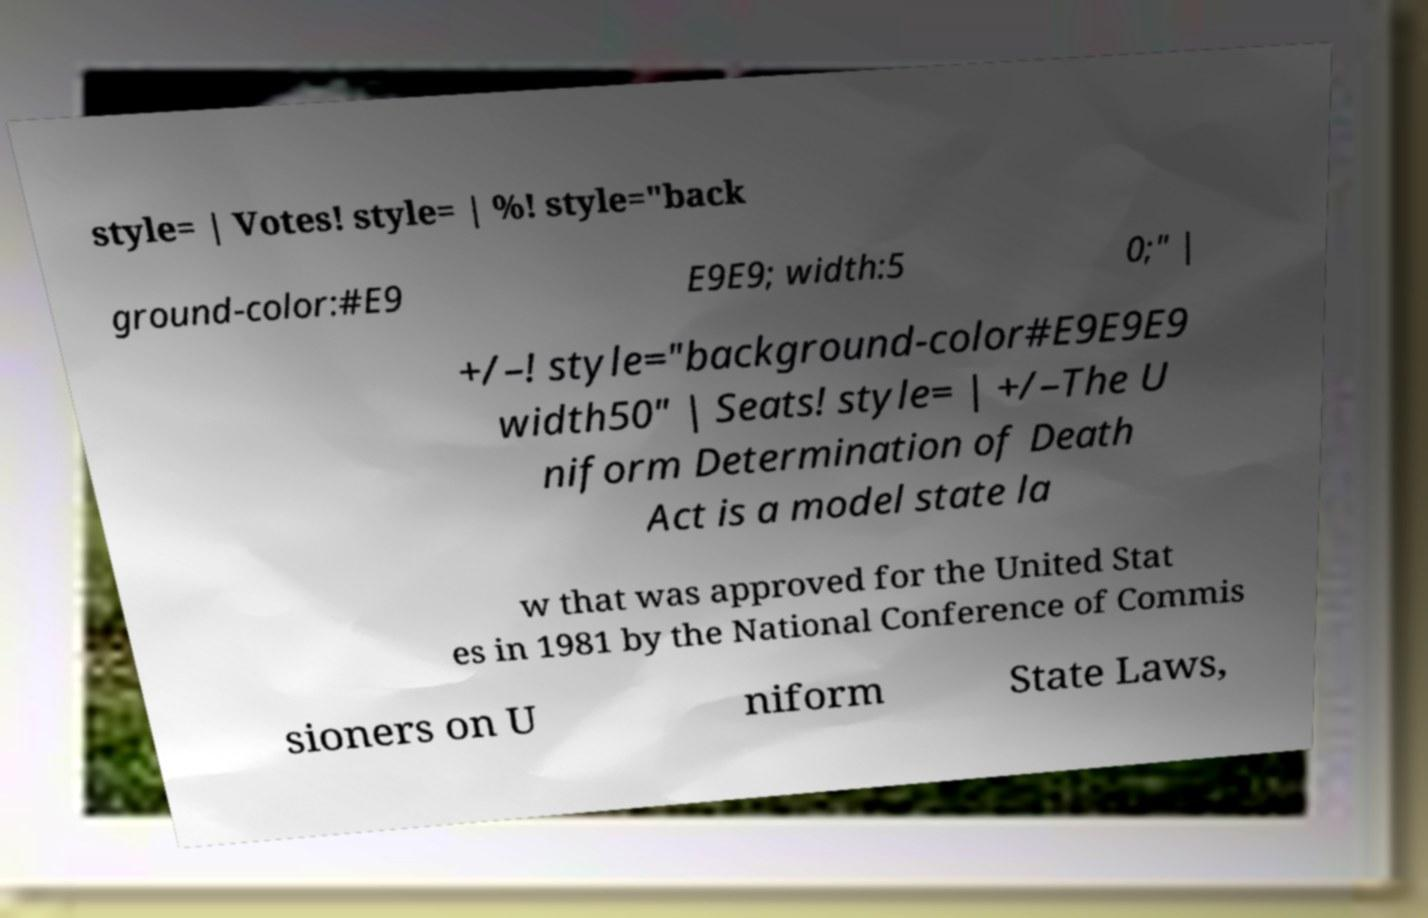Please read and relay the text visible in this image. What does it say? style= | Votes! style= | %! style="back ground-color:#E9 E9E9; width:5 0;" | +/–! style="background-color#E9E9E9 width50" | Seats! style= | +/–The U niform Determination of Death Act is a model state la w that was approved for the United Stat es in 1981 by the National Conference of Commis sioners on U niform State Laws, 